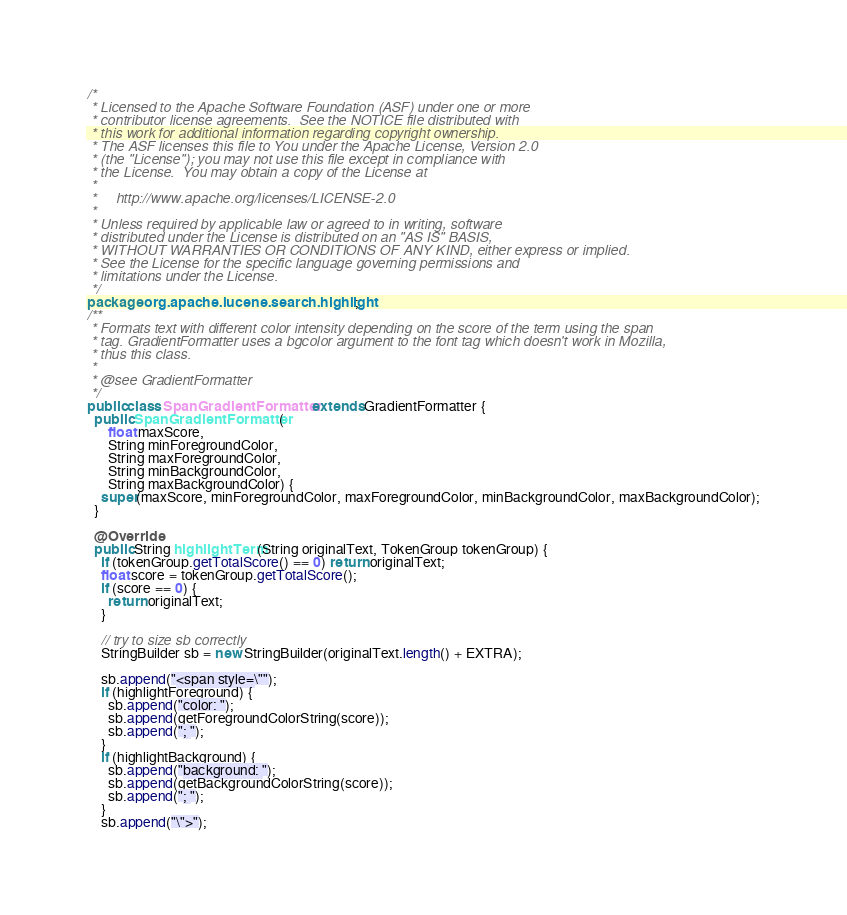Convert code to text. <code><loc_0><loc_0><loc_500><loc_500><_Java_>/*
 * Licensed to the Apache Software Foundation (ASF) under one or more
 * contributor license agreements.  See the NOTICE file distributed with
 * this work for additional information regarding copyright ownership.
 * The ASF licenses this file to You under the Apache License, Version 2.0
 * (the "License"); you may not use this file except in compliance with
 * the License.  You may obtain a copy of the License at
 *
 *     http://www.apache.org/licenses/LICENSE-2.0
 *
 * Unless required by applicable law or agreed to in writing, software
 * distributed under the License is distributed on an "AS IS" BASIS,
 * WITHOUT WARRANTIES OR CONDITIONS OF ANY KIND, either express or implied.
 * See the License for the specific language governing permissions and
 * limitations under the License.
 */
package org.apache.lucene.search.highlight;
/**
 * Formats text with different color intensity depending on the score of the term using the span
 * tag. GradientFormatter uses a bgcolor argument to the font tag which doesn't work in Mozilla,
 * thus this class.
 *
 * @see GradientFormatter
 */
public class SpanGradientFormatter extends GradientFormatter {
  public SpanGradientFormatter(
      float maxScore,
      String minForegroundColor,
      String maxForegroundColor,
      String minBackgroundColor,
      String maxBackgroundColor) {
    super(maxScore, minForegroundColor, maxForegroundColor, minBackgroundColor, maxBackgroundColor);
  }

  @Override
  public String highlightTerm(String originalText, TokenGroup tokenGroup) {
    if (tokenGroup.getTotalScore() == 0) return originalText;
    float score = tokenGroup.getTotalScore();
    if (score == 0) {
      return originalText;
    }

    // try to size sb correctly
    StringBuilder sb = new StringBuilder(originalText.length() + EXTRA);

    sb.append("<span style=\"");
    if (highlightForeground) {
      sb.append("color: ");
      sb.append(getForegroundColorString(score));
      sb.append("; ");
    }
    if (highlightBackground) {
      sb.append("background: ");
      sb.append(getBackgroundColorString(score));
      sb.append("; ");
    }
    sb.append("\">");</code> 